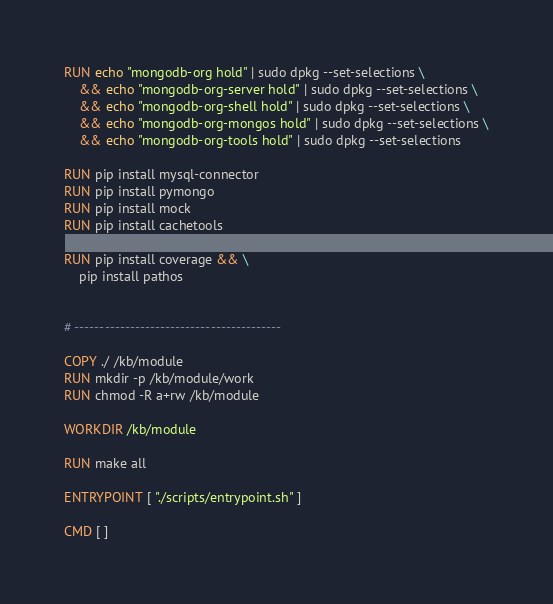Convert code to text. <code><loc_0><loc_0><loc_500><loc_500><_Dockerfile_>
RUN echo "mongodb-org hold" | sudo dpkg --set-selections \
    && echo "mongodb-org-server hold" | sudo dpkg --set-selections \
    && echo "mongodb-org-shell hold" | sudo dpkg --set-selections \
    && echo "mongodb-org-mongos hold" | sudo dpkg --set-selections \
    && echo "mongodb-org-tools hold" | sudo dpkg --set-selections

RUN pip install mysql-connector
RUN pip install pymongo
RUN pip install mock
RUN pip install cachetools

RUN pip install coverage && \
    pip install pathos


# -----------------------------------------

COPY ./ /kb/module
RUN mkdir -p /kb/module/work
RUN chmod -R a+rw /kb/module

WORKDIR /kb/module

RUN make all

ENTRYPOINT [ "./scripts/entrypoint.sh" ]

CMD [ ]
</code> 